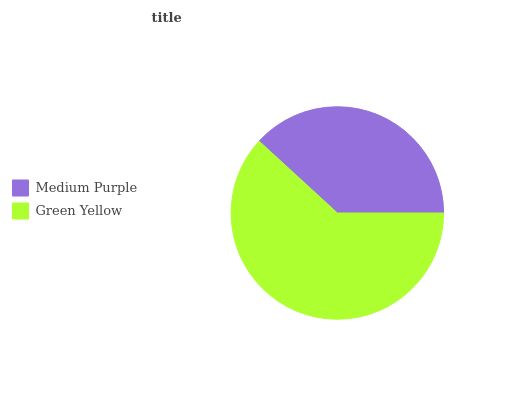Is Medium Purple the minimum?
Answer yes or no. Yes. Is Green Yellow the maximum?
Answer yes or no. Yes. Is Green Yellow the minimum?
Answer yes or no. No. Is Green Yellow greater than Medium Purple?
Answer yes or no. Yes. Is Medium Purple less than Green Yellow?
Answer yes or no. Yes. Is Medium Purple greater than Green Yellow?
Answer yes or no. No. Is Green Yellow less than Medium Purple?
Answer yes or no. No. Is Green Yellow the high median?
Answer yes or no. Yes. Is Medium Purple the low median?
Answer yes or no. Yes. Is Medium Purple the high median?
Answer yes or no. No. Is Green Yellow the low median?
Answer yes or no. No. 